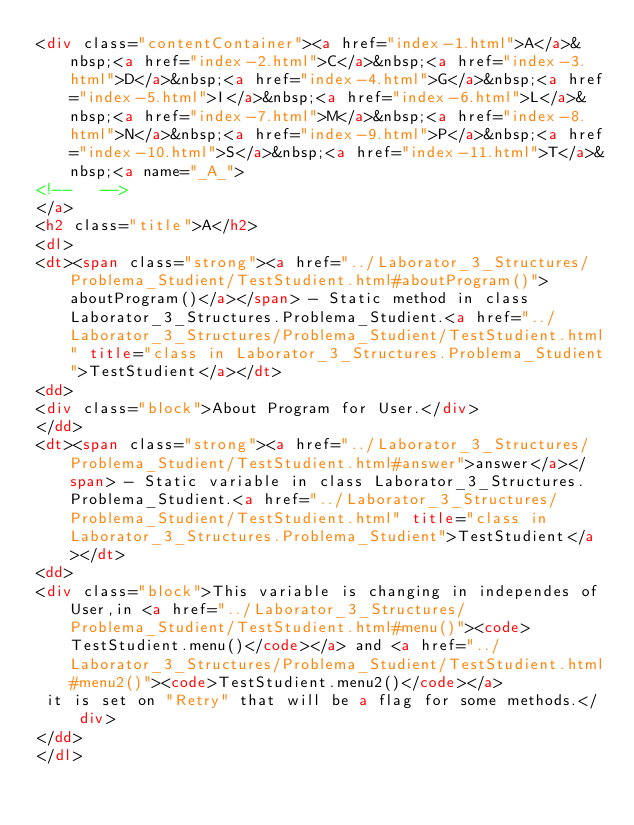<code> <loc_0><loc_0><loc_500><loc_500><_HTML_><div class="contentContainer"><a href="index-1.html">A</a>&nbsp;<a href="index-2.html">C</a>&nbsp;<a href="index-3.html">D</a>&nbsp;<a href="index-4.html">G</a>&nbsp;<a href="index-5.html">I</a>&nbsp;<a href="index-6.html">L</a>&nbsp;<a href="index-7.html">M</a>&nbsp;<a href="index-8.html">N</a>&nbsp;<a href="index-9.html">P</a>&nbsp;<a href="index-10.html">S</a>&nbsp;<a href="index-11.html">T</a>&nbsp;<a name="_A_">
<!--   -->
</a>
<h2 class="title">A</h2>
<dl>
<dt><span class="strong"><a href="../Laborator_3_Structures/Problema_Studient/TestStudient.html#aboutProgram()">aboutProgram()</a></span> - Static method in class Laborator_3_Structures.Problema_Studient.<a href="../Laborator_3_Structures/Problema_Studient/TestStudient.html" title="class in Laborator_3_Structures.Problema_Studient">TestStudient</a></dt>
<dd>
<div class="block">About Program for User.</div>
</dd>
<dt><span class="strong"><a href="../Laborator_3_Structures/Problema_Studient/TestStudient.html#answer">answer</a></span> - Static variable in class Laborator_3_Structures.Problema_Studient.<a href="../Laborator_3_Structures/Problema_Studient/TestStudient.html" title="class in Laborator_3_Structures.Problema_Studient">TestStudient</a></dt>
<dd>
<div class="block">This variable is changing in independes of User,in <a href="../Laborator_3_Structures/Problema_Studient/TestStudient.html#menu()"><code>TestStudient.menu()</code></a> and <a href="../Laborator_3_Structures/Problema_Studient/TestStudient.html#menu2()"><code>TestStudient.menu2()</code></a>
 it is set on "Retry" that will be a flag for some methods.</div>
</dd>
</dl></code> 